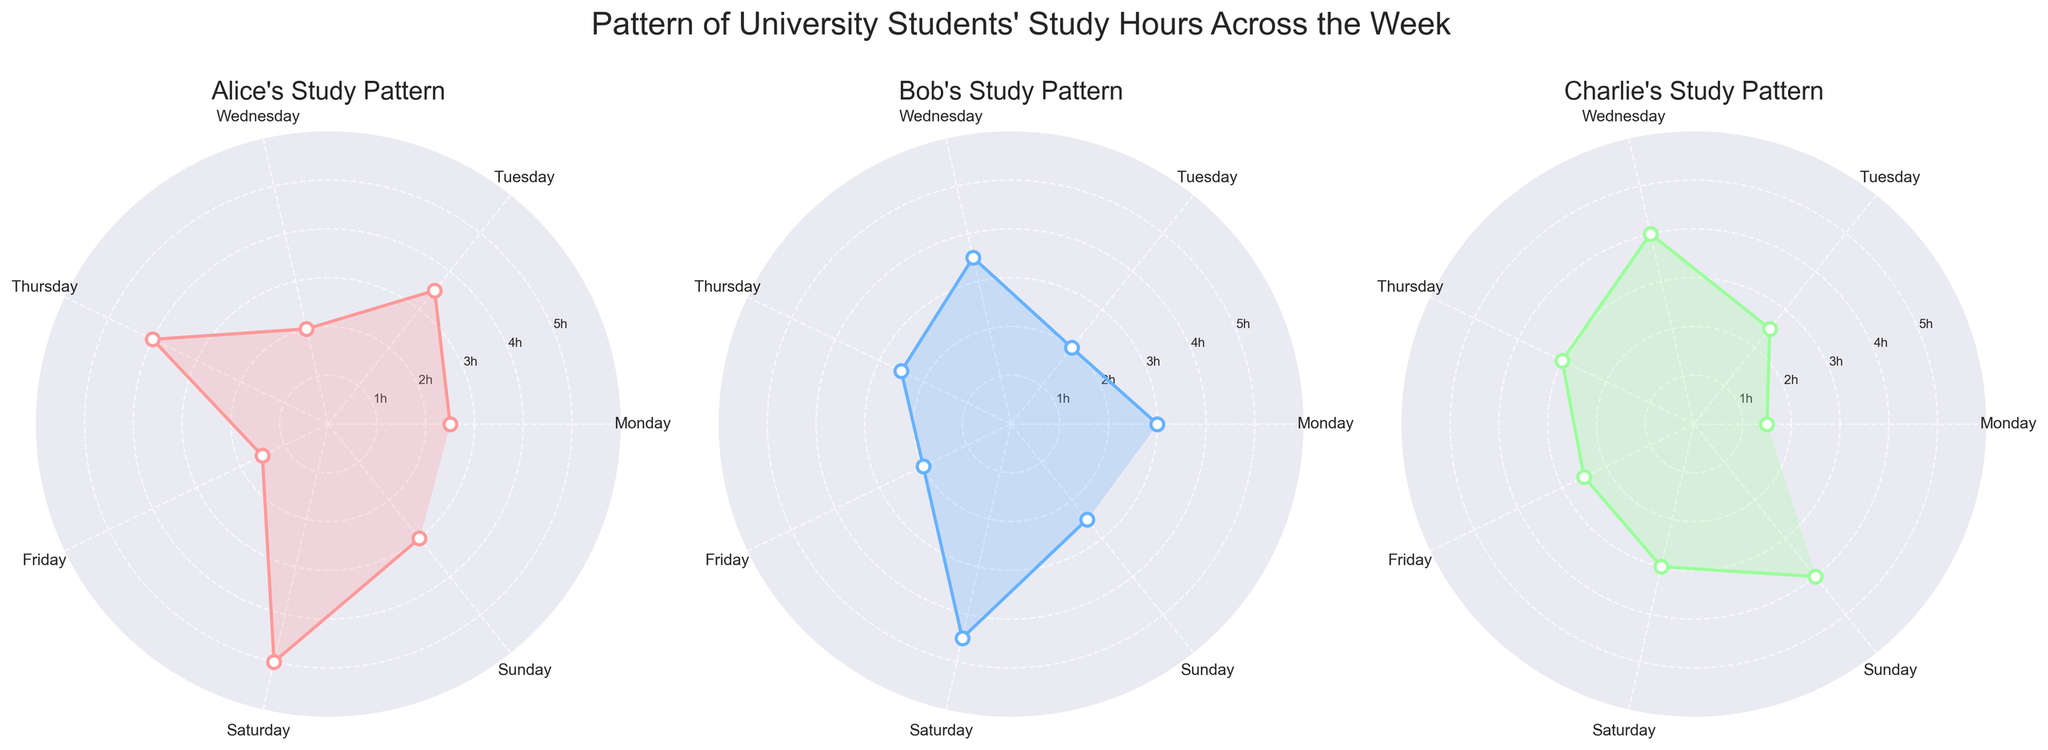How many students' study patterns are shown in the figure? The figure has three polar charts, each representing the study pattern of a different student. Simply count the number of subplots and titles for each student.
Answer: Three What are the maximum study hours recorded by Alice and Bob? For Alice, the highest point on her chart is 5 hours (Saturday). For Bob, the highest point is 4.5 hours (Saturday). Identify the maximum point on each polar chart.
Answer: 5 hours (Alice), 4.5 hours (Bob) Who studies the most on Wednesday? On Wednesday, Alice studies 2 hours, Bob studies 3.5 hours, and Charlie studies 4 hours. The polar chart for Charlie reaches the highest on this day.
Answer: Charlie What is the average study time for Charlie on weekdays (Monday to Friday)? Charlie's study hours from Monday to Friday are 1.5, 2.5, 4, 3, and 2.5 hours, respectively. Add these values and divide by 5: (1.5 + 2.5 + 4 + 3 + 2.5)/5 = 13.5/5 = 2.7 hours.
Answer: 2.7 hours On which day does Alice study the least and how many hours does she study on that day? For Alice, the lowest point on her chart is on Friday with 1.5 hours of study.
Answer: Friday, 1.5 hours How do Bob's study hours on Sunday compare to his study hours on Tuesday? Bob studies 2.5 hours on Sunday and 2 hours on Tuesday. Comparing these, Bob studies 0.5 hours more on Sunday than on Tuesday.
Answer: 0.5 hours more on Sunday Which student has the most consistent study pattern throughout the week? Examine the variability of each student's polar chart. Alice's chart shows larger fluctuations with peaks and troughs, while Bob and Charlie have relatively less variation. By visually evaluating the smoothness, Charlie's chart appears the most consistent.
Answer: Charlie What is the total number of hours Alice studies during the weekend (Saturday and Sunday)? Alice studies 5 hours on Saturday and 3 hours on Sunday. Add these values: 5 + 3 = 8 hours.
Answer: 8 hours Which student's study pattern shows the largest increase in study hours from one day to the next? Identify the specific days and hours. Charlie's chart shows a significant jump from Wednesday (4 hours) to Thursday (3 hours), and then to Friday (2.5 hours), suggesting a large increase but ultimately the highest jump might depend on specifics. Given the observed pattern, Wednesday to Thursday for Charlie shows a big decrease rather than increase which means Alice’s switch from Thursday to Saturday is most prominent from 4 to 5 hours (Thursday to Saturday). Therefore, revisit comparisons.
Answer: Charlie from Wednesday to Thursday shows 4 to 3 hrs 